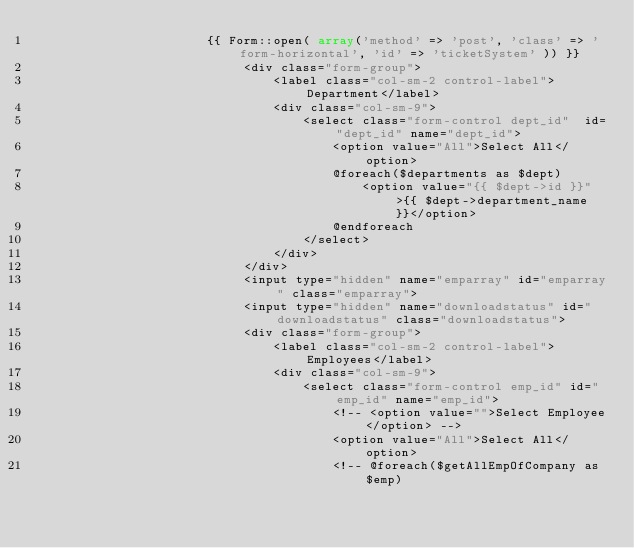Convert code to text. <code><loc_0><loc_0><loc_500><loc_500><_PHP_>                       {{ Form::open( array('method' => 'post', 'class' => 'form-horizontal', 'id' => 'ticketSystem' )) }}  
                            <div class="form-group">
                                <label class="col-sm-2 control-label">Department</label>
                                <div class="col-sm-9">
                                    <select class="form-control dept_id"  id="dept_id" name="dept_id">
                                        <option value="All">Select All</option>
                                        @foreach($departments as $dept)
                                            <option value="{{ $dept->id }}">{{ $dept->department_name }}</option>
                                        @endforeach
                                    </select>
                                </div>
                            </div>
                            <input type="hidden" name="emparray" id="emparray" class="emparray">
                            <input type="hidden" name="downloadstatus" id="downloadstatus" class="downloadstatus">
                            <div class="form-group">
                                <label class="col-sm-2 control-label">Employees</label>
                                <div class="col-sm-9">
                                    <select class="form-control emp_id" id="emp_id" name="emp_id">
                                        <!-- <option value="">Select Employee</option> -->
                                        <option value="All">Select All</option>
                                        <!-- @foreach($getAllEmpOfCompany as $emp)</code> 